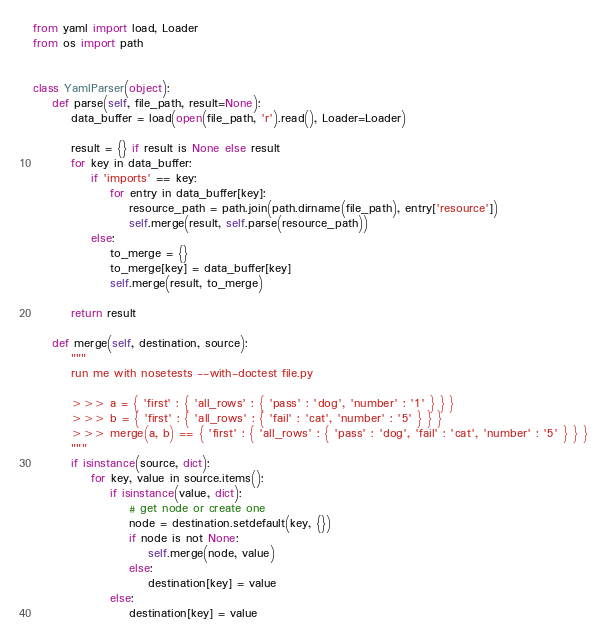<code> <loc_0><loc_0><loc_500><loc_500><_Python_>from yaml import load, Loader
from os import path


class YamlParser(object):
    def parse(self, file_path, result=None):
        data_buffer = load(open(file_path, 'r').read(), Loader=Loader)

        result = {} if result is None else result
        for key in data_buffer:
            if 'imports' == key:
                for entry in data_buffer[key]:
                    resource_path = path.join(path.dirname(file_path), entry['resource'])
                    self.merge(result, self.parse(resource_path))
            else:
                to_merge = {}
                to_merge[key] = data_buffer[key]
                self.merge(result, to_merge)

        return result

    def merge(self, destination, source):
        """
        run me with nosetests --with-doctest file.py

        >>> a = { 'first' : { 'all_rows' : { 'pass' : 'dog', 'number' : '1' } } }
        >>> b = { 'first' : { 'all_rows' : { 'fail' : 'cat', 'number' : '5' } } }
        >>> merge(a, b) == { 'first' : { 'all_rows' : { 'pass' : 'dog', 'fail' : 'cat', 'number' : '5' } } }
        """
        if isinstance(source, dict):
            for key, value in source.items():
                if isinstance(value, dict):
                    # get node or create one
                    node = destination.setdefault(key, {})
                    if node is not None:
                        self.merge(node, value)
                    else:
                        destination[key] = value
                else:
                    destination[key] = value
</code> 